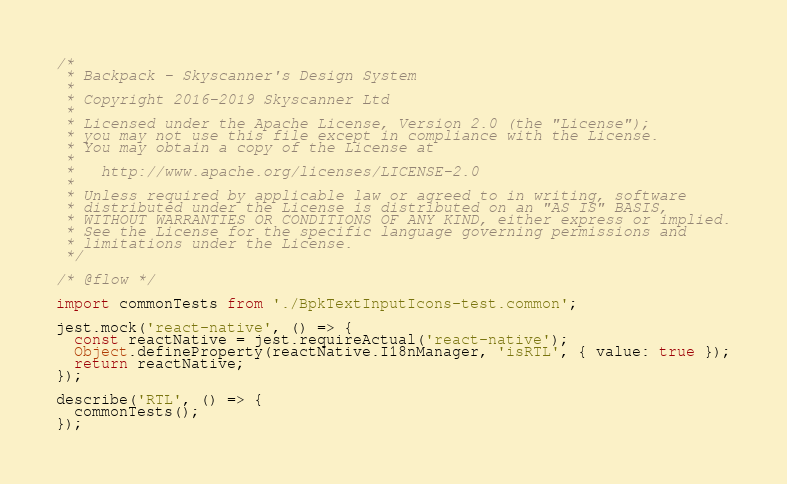Convert code to text. <code><loc_0><loc_0><loc_500><loc_500><_JavaScript_>/*
 * Backpack - Skyscanner's Design System
 *
 * Copyright 2016-2019 Skyscanner Ltd
 *
 * Licensed under the Apache License, Version 2.0 (the "License");
 * you may not use this file except in compliance with the License.
 * You may obtain a copy of the License at
 *
 *   http://www.apache.org/licenses/LICENSE-2.0
 *
 * Unless required by applicable law or agreed to in writing, software
 * distributed under the License is distributed on an "AS IS" BASIS,
 * WITHOUT WARRANTIES OR CONDITIONS OF ANY KIND, either express or implied.
 * See the License for the specific language governing permissions and
 * limitations under the License.
 */

/* @flow */

import commonTests from './BpkTextInputIcons-test.common';

jest.mock('react-native', () => {
  const reactNative = jest.requireActual('react-native');
  Object.defineProperty(reactNative.I18nManager, 'isRTL', { value: true });
  return reactNative;
});

describe('RTL', () => {
  commonTests();
});
</code> 